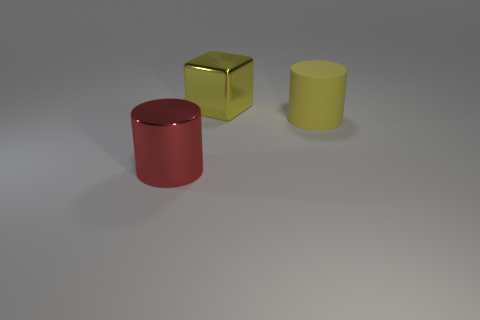Is there anything else that is the same material as the yellow cylinder?
Give a very brief answer. No. What number of other things are the same shape as the big matte object?
Offer a very short reply. 1. There is a object that is left of the yellow rubber cylinder and to the right of the large shiny cylinder; what is its color?
Provide a succinct answer. Yellow. What is the color of the large matte thing?
Your answer should be very brief. Yellow. Does the big yellow block have the same material as the large yellow object that is right of the large cube?
Offer a terse response. No. The large object that is the same material as the block is what shape?
Provide a succinct answer. Cylinder. What color is the metallic object that is the same size as the shiny cylinder?
Offer a terse response. Yellow. There is a cylinder that is on the right side of the yellow metal cube; is it the same size as the large red cylinder?
Provide a succinct answer. Yes. Is the color of the big rubber object the same as the metallic block?
Your answer should be very brief. Yes. What number of gray objects are there?
Make the answer very short. 0. 